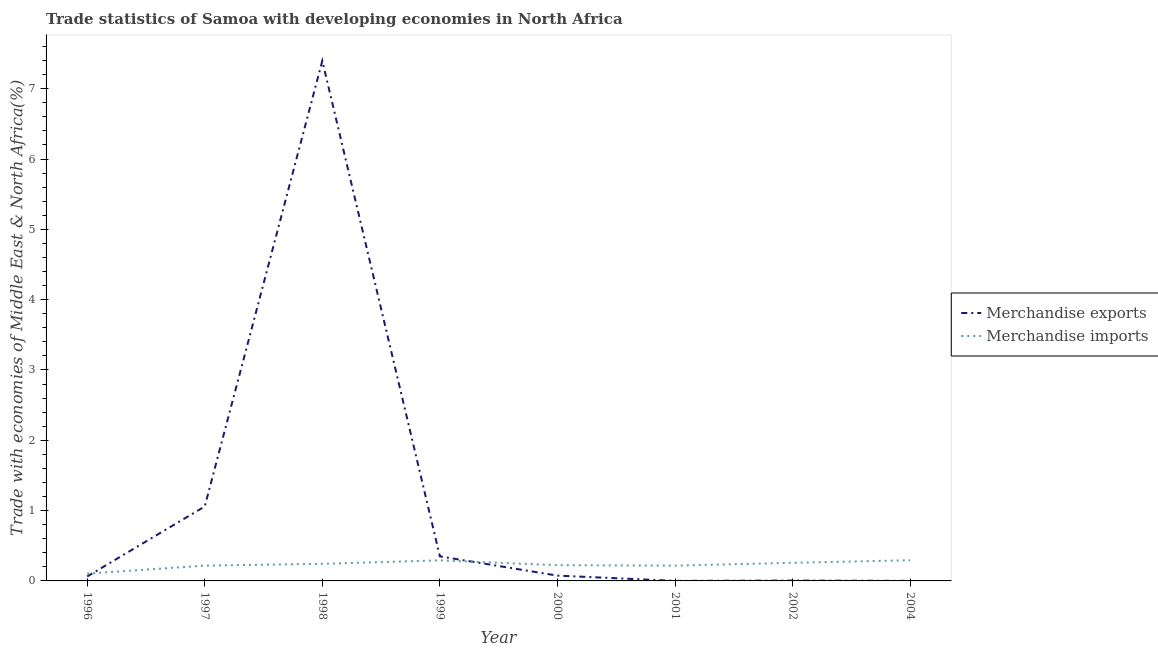Does the line corresponding to merchandise imports intersect with the line corresponding to merchandise exports?
Ensure brevity in your answer.  Yes. What is the merchandise imports in 1998?
Your answer should be compact. 0.24. Across all years, what is the maximum merchandise imports?
Keep it short and to the point. 0.29. Across all years, what is the minimum merchandise exports?
Provide a short and direct response. 0. In which year was the merchandise exports maximum?
Offer a terse response. 1998. What is the total merchandise imports in the graph?
Provide a succinct answer. 1.85. What is the difference between the merchandise exports in 1997 and that in 2001?
Your answer should be compact. 1.06. What is the difference between the merchandise imports in 1998 and the merchandise exports in 2000?
Provide a short and direct response. 0.17. What is the average merchandise imports per year?
Offer a very short reply. 0.23. In the year 1997, what is the difference between the merchandise imports and merchandise exports?
Offer a very short reply. -0.84. In how many years, is the merchandise imports greater than 1.8 %?
Your answer should be very brief. 0. What is the ratio of the merchandise exports in 1998 to that in 2004?
Your answer should be very brief. 8671.73. Is the merchandise imports in 1997 less than that in 2000?
Give a very brief answer. Yes. Is the difference between the merchandise exports in 1998 and 1999 greater than the difference between the merchandise imports in 1998 and 1999?
Give a very brief answer. Yes. What is the difference between the highest and the second highest merchandise exports?
Your answer should be very brief. 6.34. What is the difference between the highest and the lowest merchandise exports?
Make the answer very short. 7.4. Does the merchandise imports monotonically increase over the years?
Ensure brevity in your answer.  No. How many lines are there?
Offer a terse response. 2. What is the difference between two consecutive major ticks on the Y-axis?
Your answer should be compact. 1. Does the graph contain any zero values?
Ensure brevity in your answer.  No. How many legend labels are there?
Give a very brief answer. 2. What is the title of the graph?
Offer a terse response. Trade statistics of Samoa with developing economies in North Africa. Does "Females" appear as one of the legend labels in the graph?
Your answer should be compact. No. What is the label or title of the X-axis?
Ensure brevity in your answer.  Year. What is the label or title of the Y-axis?
Ensure brevity in your answer.  Trade with economies of Middle East & North Africa(%). What is the Trade with economies of Middle East & North Africa(%) of Merchandise exports in 1996?
Your response must be concise. 0.06. What is the Trade with economies of Middle East & North Africa(%) in Merchandise imports in 1996?
Ensure brevity in your answer.  0.1. What is the Trade with economies of Middle East & North Africa(%) of Merchandise exports in 1997?
Your response must be concise. 1.06. What is the Trade with economies of Middle East & North Africa(%) in Merchandise imports in 1997?
Keep it short and to the point. 0.22. What is the Trade with economies of Middle East & North Africa(%) in Merchandise exports in 1998?
Ensure brevity in your answer.  7.4. What is the Trade with economies of Middle East & North Africa(%) in Merchandise imports in 1998?
Provide a succinct answer. 0.24. What is the Trade with economies of Middle East & North Africa(%) in Merchandise exports in 1999?
Make the answer very short. 0.35. What is the Trade with economies of Middle East & North Africa(%) in Merchandise imports in 1999?
Keep it short and to the point. 0.29. What is the Trade with economies of Middle East & North Africa(%) in Merchandise exports in 2000?
Your response must be concise. 0.08. What is the Trade with economies of Middle East & North Africa(%) of Merchandise imports in 2000?
Give a very brief answer. 0.22. What is the Trade with economies of Middle East & North Africa(%) in Merchandise exports in 2001?
Make the answer very short. 0. What is the Trade with economies of Middle East & North Africa(%) of Merchandise imports in 2001?
Keep it short and to the point. 0.22. What is the Trade with economies of Middle East & North Africa(%) in Merchandise exports in 2002?
Make the answer very short. 0. What is the Trade with economies of Middle East & North Africa(%) of Merchandise imports in 2002?
Make the answer very short. 0.26. What is the Trade with economies of Middle East & North Africa(%) in Merchandise exports in 2004?
Your response must be concise. 0. What is the Trade with economies of Middle East & North Africa(%) of Merchandise imports in 2004?
Your answer should be compact. 0.29. Across all years, what is the maximum Trade with economies of Middle East & North Africa(%) in Merchandise exports?
Make the answer very short. 7.4. Across all years, what is the maximum Trade with economies of Middle East & North Africa(%) in Merchandise imports?
Ensure brevity in your answer.  0.29. Across all years, what is the minimum Trade with economies of Middle East & North Africa(%) in Merchandise exports?
Offer a terse response. 0. Across all years, what is the minimum Trade with economies of Middle East & North Africa(%) of Merchandise imports?
Your answer should be very brief. 0.1. What is the total Trade with economies of Middle East & North Africa(%) of Merchandise exports in the graph?
Offer a terse response. 8.95. What is the total Trade with economies of Middle East & North Africa(%) of Merchandise imports in the graph?
Keep it short and to the point. 1.85. What is the difference between the Trade with economies of Middle East & North Africa(%) of Merchandise exports in 1996 and that in 1997?
Make the answer very short. -1. What is the difference between the Trade with economies of Middle East & North Africa(%) in Merchandise imports in 1996 and that in 1997?
Make the answer very short. -0.11. What is the difference between the Trade with economies of Middle East & North Africa(%) of Merchandise exports in 1996 and that in 1998?
Your answer should be compact. -7.33. What is the difference between the Trade with economies of Middle East & North Africa(%) of Merchandise imports in 1996 and that in 1998?
Provide a succinct answer. -0.14. What is the difference between the Trade with economies of Middle East & North Africa(%) of Merchandise exports in 1996 and that in 1999?
Your response must be concise. -0.29. What is the difference between the Trade with economies of Middle East & North Africa(%) in Merchandise imports in 1996 and that in 1999?
Your response must be concise. -0.19. What is the difference between the Trade with economies of Middle East & North Africa(%) in Merchandise exports in 1996 and that in 2000?
Provide a short and direct response. -0.01. What is the difference between the Trade with economies of Middle East & North Africa(%) in Merchandise imports in 1996 and that in 2000?
Provide a short and direct response. -0.12. What is the difference between the Trade with economies of Middle East & North Africa(%) in Merchandise exports in 1996 and that in 2001?
Ensure brevity in your answer.  0.06. What is the difference between the Trade with economies of Middle East & North Africa(%) of Merchandise imports in 1996 and that in 2001?
Your response must be concise. -0.11. What is the difference between the Trade with economies of Middle East & North Africa(%) in Merchandise exports in 1996 and that in 2002?
Provide a short and direct response. 0.06. What is the difference between the Trade with economies of Middle East & North Africa(%) in Merchandise imports in 1996 and that in 2002?
Give a very brief answer. -0.15. What is the difference between the Trade with economies of Middle East & North Africa(%) of Merchandise exports in 1996 and that in 2004?
Ensure brevity in your answer.  0.06. What is the difference between the Trade with economies of Middle East & North Africa(%) of Merchandise imports in 1996 and that in 2004?
Keep it short and to the point. -0.19. What is the difference between the Trade with economies of Middle East & North Africa(%) in Merchandise exports in 1997 and that in 1998?
Ensure brevity in your answer.  -6.34. What is the difference between the Trade with economies of Middle East & North Africa(%) of Merchandise imports in 1997 and that in 1998?
Your answer should be compact. -0.03. What is the difference between the Trade with economies of Middle East & North Africa(%) of Merchandise exports in 1997 and that in 1999?
Your answer should be compact. 0.71. What is the difference between the Trade with economies of Middle East & North Africa(%) in Merchandise imports in 1997 and that in 1999?
Your answer should be compact. -0.07. What is the difference between the Trade with economies of Middle East & North Africa(%) in Merchandise exports in 1997 and that in 2000?
Your answer should be very brief. 0.98. What is the difference between the Trade with economies of Middle East & North Africa(%) in Merchandise imports in 1997 and that in 2000?
Give a very brief answer. -0.01. What is the difference between the Trade with economies of Middle East & North Africa(%) in Merchandise exports in 1997 and that in 2001?
Provide a succinct answer. 1.06. What is the difference between the Trade with economies of Middle East & North Africa(%) in Merchandise imports in 1997 and that in 2001?
Ensure brevity in your answer.  0. What is the difference between the Trade with economies of Middle East & North Africa(%) of Merchandise exports in 1997 and that in 2002?
Ensure brevity in your answer.  1.05. What is the difference between the Trade with economies of Middle East & North Africa(%) of Merchandise imports in 1997 and that in 2002?
Your answer should be compact. -0.04. What is the difference between the Trade with economies of Middle East & North Africa(%) of Merchandise exports in 1997 and that in 2004?
Your answer should be compact. 1.06. What is the difference between the Trade with economies of Middle East & North Africa(%) of Merchandise imports in 1997 and that in 2004?
Keep it short and to the point. -0.08. What is the difference between the Trade with economies of Middle East & North Africa(%) of Merchandise exports in 1998 and that in 1999?
Ensure brevity in your answer.  7.05. What is the difference between the Trade with economies of Middle East & North Africa(%) in Merchandise imports in 1998 and that in 1999?
Make the answer very short. -0.05. What is the difference between the Trade with economies of Middle East & North Africa(%) of Merchandise exports in 1998 and that in 2000?
Offer a very short reply. 7.32. What is the difference between the Trade with economies of Middle East & North Africa(%) of Merchandise imports in 1998 and that in 2000?
Give a very brief answer. 0.02. What is the difference between the Trade with economies of Middle East & North Africa(%) in Merchandise exports in 1998 and that in 2001?
Make the answer very short. 7.4. What is the difference between the Trade with economies of Middle East & North Africa(%) in Merchandise imports in 1998 and that in 2001?
Offer a terse response. 0.03. What is the difference between the Trade with economies of Middle East & North Africa(%) in Merchandise exports in 1998 and that in 2002?
Make the answer very short. 7.39. What is the difference between the Trade with economies of Middle East & North Africa(%) of Merchandise imports in 1998 and that in 2002?
Your response must be concise. -0.01. What is the difference between the Trade with economies of Middle East & North Africa(%) in Merchandise exports in 1998 and that in 2004?
Provide a short and direct response. 7.4. What is the difference between the Trade with economies of Middle East & North Africa(%) of Merchandise imports in 1998 and that in 2004?
Offer a terse response. -0.05. What is the difference between the Trade with economies of Middle East & North Africa(%) in Merchandise exports in 1999 and that in 2000?
Your response must be concise. 0.27. What is the difference between the Trade with economies of Middle East & North Africa(%) of Merchandise imports in 1999 and that in 2000?
Offer a very short reply. 0.07. What is the difference between the Trade with economies of Middle East & North Africa(%) of Merchandise exports in 1999 and that in 2001?
Give a very brief answer. 0.35. What is the difference between the Trade with economies of Middle East & North Africa(%) of Merchandise imports in 1999 and that in 2001?
Give a very brief answer. 0.08. What is the difference between the Trade with economies of Middle East & North Africa(%) of Merchandise exports in 1999 and that in 2002?
Your answer should be compact. 0.34. What is the difference between the Trade with economies of Middle East & North Africa(%) of Merchandise imports in 1999 and that in 2002?
Give a very brief answer. 0.04. What is the difference between the Trade with economies of Middle East & North Africa(%) in Merchandise exports in 1999 and that in 2004?
Offer a terse response. 0.35. What is the difference between the Trade with economies of Middle East & North Africa(%) of Merchandise imports in 1999 and that in 2004?
Your response must be concise. -0. What is the difference between the Trade with economies of Middle East & North Africa(%) in Merchandise exports in 2000 and that in 2001?
Your answer should be compact. 0.07. What is the difference between the Trade with economies of Middle East & North Africa(%) in Merchandise imports in 2000 and that in 2001?
Your answer should be compact. 0.01. What is the difference between the Trade with economies of Middle East & North Africa(%) of Merchandise exports in 2000 and that in 2002?
Provide a short and direct response. 0.07. What is the difference between the Trade with economies of Middle East & North Africa(%) in Merchandise imports in 2000 and that in 2002?
Provide a short and direct response. -0.03. What is the difference between the Trade with economies of Middle East & North Africa(%) of Merchandise exports in 2000 and that in 2004?
Provide a succinct answer. 0.07. What is the difference between the Trade with economies of Middle East & North Africa(%) in Merchandise imports in 2000 and that in 2004?
Your answer should be very brief. -0.07. What is the difference between the Trade with economies of Middle East & North Africa(%) in Merchandise exports in 2001 and that in 2002?
Offer a very short reply. -0. What is the difference between the Trade with economies of Middle East & North Africa(%) in Merchandise imports in 2001 and that in 2002?
Your response must be concise. -0.04. What is the difference between the Trade with economies of Middle East & North Africa(%) of Merchandise exports in 2001 and that in 2004?
Ensure brevity in your answer.  0. What is the difference between the Trade with economies of Middle East & North Africa(%) in Merchandise imports in 2001 and that in 2004?
Your answer should be compact. -0.08. What is the difference between the Trade with economies of Middle East & North Africa(%) in Merchandise exports in 2002 and that in 2004?
Make the answer very short. 0. What is the difference between the Trade with economies of Middle East & North Africa(%) in Merchandise imports in 2002 and that in 2004?
Offer a terse response. -0.04. What is the difference between the Trade with economies of Middle East & North Africa(%) of Merchandise exports in 1996 and the Trade with economies of Middle East & North Africa(%) of Merchandise imports in 1997?
Your answer should be very brief. -0.15. What is the difference between the Trade with economies of Middle East & North Africa(%) in Merchandise exports in 1996 and the Trade with economies of Middle East & North Africa(%) in Merchandise imports in 1998?
Ensure brevity in your answer.  -0.18. What is the difference between the Trade with economies of Middle East & North Africa(%) of Merchandise exports in 1996 and the Trade with economies of Middle East & North Africa(%) of Merchandise imports in 1999?
Your answer should be very brief. -0.23. What is the difference between the Trade with economies of Middle East & North Africa(%) of Merchandise exports in 1996 and the Trade with economies of Middle East & North Africa(%) of Merchandise imports in 2000?
Provide a short and direct response. -0.16. What is the difference between the Trade with economies of Middle East & North Africa(%) of Merchandise exports in 1996 and the Trade with economies of Middle East & North Africa(%) of Merchandise imports in 2001?
Your response must be concise. -0.15. What is the difference between the Trade with economies of Middle East & North Africa(%) of Merchandise exports in 1996 and the Trade with economies of Middle East & North Africa(%) of Merchandise imports in 2002?
Provide a succinct answer. -0.19. What is the difference between the Trade with economies of Middle East & North Africa(%) in Merchandise exports in 1996 and the Trade with economies of Middle East & North Africa(%) in Merchandise imports in 2004?
Your answer should be compact. -0.23. What is the difference between the Trade with economies of Middle East & North Africa(%) in Merchandise exports in 1997 and the Trade with economies of Middle East & North Africa(%) in Merchandise imports in 1998?
Ensure brevity in your answer.  0.82. What is the difference between the Trade with economies of Middle East & North Africa(%) of Merchandise exports in 1997 and the Trade with economies of Middle East & North Africa(%) of Merchandise imports in 1999?
Ensure brevity in your answer.  0.77. What is the difference between the Trade with economies of Middle East & North Africa(%) of Merchandise exports in 1997 and the Trade with economies of Middle East & North Africa(%) of Merchandise imports in 2000?
Keep it short and to the point. 0.83. What is the difference between the Trade with economies of Middle East & North Africa(%) in Merchandise exports in 1997 and the Trade with economies of Middle East & North Africa(%) in Merchandise imports in 2001?
Provide a succinct answer. 0.84. What is the difference between the Trade with economies of Middle East & North Africa(%) of Merchandise exports in 1997 and the Trade with economies of Middle East & North Africa(%) of Merchandise imports in 2002?
Offer a terse response. 0.8. What is the difference between the Trade with economies of Middle East & North Africa(%) of Merchandise exports in 1997 and the Trade with economies of Middle East & North Africa(%) of Merchandise imports in 2004?
Your answer should be compact. 0.76. What is the difference between the Trade with economies of Middle East & North Africa(%) of Merchandise exports in 1998 and the Trade with economies of Middle East & North Africa(%) of Merchandise imports in 1999?
Your answer should be compact. 7.1. What is the difference between the Trade with economies of Middle East & North Africa(%) in Merchandise exports in 1998 and the Trade with economies of Middle East & North Africa(%) in Merchandise imports in 2000?
Keep it short and to the point. 7.17. What is the difference between the Trade with economies of Middle East & North Africa(%) of Merchandise exports in 1998 and the Trade with economies of Middle East & North Africa(%) of Merchandise imports in 2001?
Offer a very short reply. 7.18. What is the difference between the Trade with economies of Middle East & North Africa(%) in Merchandise exports in 1998 and the Trade with economies of Middle East & North Africa(%) in Merchandise imports in 2002?
Keep it short and to the point. 7.14. What is the difference between the Trade with economies of Middle East & North Africa(%) in Merchandise exports in 1998 and the Trade with economies of Middle East & North Africa(%) in Merchandise imports in 2004?
Your answer should be very brief. 7.1. What is the difference between the Trade with economies of Middle East & North Africa(%) in Merchandise exports in 1999 and the Trade with economies of Middle East & North Africa(%) in Merchandise imports in 2000?
Offer a very short reply. 0.13. What is the difference between the Trade with economies of Middle East & North Africa(%) of Merchandise exports in 1999 and the Trade with economies of Middle East & North Africa(%) of Merchandise imports in 2001?
Your answer should be compact. 0.13. What is the difference between the Trade with economies of Middle East & North Africa(%) in Merchandise exports in 1999 and the Trade with economies of Middle East & North Africa(%) in Merchandise imports in 2002?
Keep it short and to the point. 0.09. What is the difference between the Trade with economies of Middle East & North Africa(%) in Merchandise exports in 1999 and the Trade with economies of Middle East & North Africa(%) in Merchandise imports in 2004?
Your answer should be very brief. 0.05. What is the difference between the Trade with economies of Middle East & North Africa(%) in Merchandise exports in 2000 and the Trade with economies of Middle East & North Africa(%) in Merchandise imports in 2001?
Your answer should be compact. -0.14. What is the difference between the Trade with economies of Middle East & North Africa(%) of Merchandise exports in 2000 and the Trade with economies of Middle East & North Africa(%) of Merchandise imports in 2002?
Your answer should be compact. -0.18. What is the difference between the Trade with economies of Middle East & North Africa(%) in Merchandise exports in 2000 and the Trade with economies of Middle East & North Africa(%) in Merchandise imports in 2004?
Provide a succinct answer. -0.22. What is the difference between the Trade with economies of Middle East & North Africa(%) in Merchandise exports in 2001 and the Trade with economies of Middle East & North Africa(%) in Merchandise imports in 2002?
Provide a succinct answer. -0.26. What is the difference between the Trade with economies of Middle East & North Africa(%) in Merchandise exports in 2001 and the Trade with economies of Middle East & North Africa(%) in Merchandise imports in 2004?
Offer a terse response. -0.29. What is the difference between the Trade with economies of Middle East & North Africa(%) of Merchandise exports in 2002 and the Trade with economies of Middle East & North Africa(%) of Merchandise imports in 2004?
Keep it short and to the point. -0.29. What is the average Trade with economies of Middle East & North Africa(%) in Merchandise exports per year?
Provide a short and direct response. 1.12. What is the average Trade with economies of Middle East & North Africa(%) of Merchandise imports per year?
Make the answer very short. 0.23. In the year 1996, what is the difference between the Trade with economies of Middle East & North Africa(%) in Merchandise exports and Trade with economies of Middle East & North Africa(%) in Merchandise imports?
Make the answer very short. -0.04. In the year 1997, what is the difference between the Trade with economies of Middle East & North Africa(%) of Merchandise exports and Trade with economies of Middle East & North Africa(%) of Merchandise imports?
Give a very brief answer. 0.84. In the year 1998, what is the difference between the Trade with economies of Middle East & North Africa(%) in Merchandise exports and Trade with economies of Middle East & North Africa(%) in Merchandise imports?
Make the answer very short. 7.15. In the year 1999, what is the difference between the Trade with economies of Middle East & North Africa(%) of Merchandise exports and Trade with economies of Middle East & North Africa(%) of Merchandise imports?
Your answer should be compact. 0.06. In the year 2000, what is the difference between the Trade with economies of Middle East & North Africa(%) of Merchandise exports and Trade with economies of Middle East & North Africa(%) of Merchandise imports?
Offer a very short reply. -0.15. In the year 2001, what is the difference between the Trade with economies of Middle East & North Africa(%) in Merchandise exports and Trade with economies of Middle East & North Africa(%) in Merchandise imports?
Your answer should be very brief. -0.22. In the year 2002, what is the difference between the Trade with economies of Middle East & North Africa(%) in Merchandise exports and Trade with economies of Middle East & North Africa(%) in Merchandise imports?
Provide a short and direct response. -0.25. In the year 2004, what is the difference between the Trade with economies of Middle East & North Africa(%) of Merchandise exports and Trade with economies of Middle East & North Africa(%) of Merchandise imports?
Provide a short and direct response. -0.29. What is the ratio of the Trade with economies of Middle East & North Africa(%) in Merchandise exports in 1996 to that in 1997?
Your answer should be very brief. 0.06. What is the ratio of the Trade with economies of Middle East & North Africa(%) in Merchandise imports in 1996 to that in 1997?
Ensure brevity in your answer.  0.48. What is the ratio of the Trade with economies of Middle East & North Africa(%) of Merchandise exports in 1996 to that in 1998?
Give a very brief answer. 0.01. What is the ratio of the Trade with economies of Middle East & North Africa(%) in Merchandise imports in 1996 to that in 1998?
Your answer should be compact. 0.43. What is the ratio of the Trade with economies of Middle East & North Africa(%) in Merchandise exports in 1996 to that in 1999?
Give a very brief answer. 0.18. What is the ratio of the Trade with economies of Middle East & North Africa(%) of Merchandise imports in 1996 to that in 1999?
Ensure brevity in your answer.  0.35. What is the ratio of the Trade with economies of Middle East & North Africa(%) in Merchandise exports in 1996 to that in 2000?
Ensure brevity in your answer.  0.84. What is the ratio of the Trade with economies of Middle East & North Africa(%) in Merchandise imports in 1996 to that in 2000?
Your answer should be very brief. 0.46. What is the ratio of the Trade with economies of Middle East & North Africa(%) of Merchandise exports in 1996 to that in 2001?
Offer a terse response. 70.3. What is the ratio of the Trade with economies of Middle East & North Africa(%) in Merchandise imports in 1996 to that in 2001?
Your answer should be compact. 0.48. What is the ratio of the Trade with economies of Middle East & North Africa(%) in Merchandise exports in 1996 to that in 2002?
Ensure brevity in your answer.  12.73. What is the ratio of the Trade with economies of Middle East & North Africa(%) of Merchandise imports in 1996 to that in 2002?
Provide a short and direct response. 0.4. What is the ratio of the Trade with economies of Middle East & North Africa(%) in Merchandise exports in 1996 to that in 2004?
Provide a short and direct response. 74.07. What is the ratio of the Trade with economies of Middle East & North Africa(%) in Merchandise imports in 1996 to that in 2004?
Ensure brevity in your answer.  0.35. What is the ratio of the Trade with economies of Middle East & North Africa(%) in Merchandise exports in 1997 to that in 1998?
Provide a succinct answer. 0.14. What is the ratio of the Trade with economies of Middle East & North Africa(%) in Merchandise imports in 1997 to that in 1998?
Ensure brevity in your answer.  0.9. What is the ratio of the Trade with economies of Middle East & North Africa(%) in Merchandise exports in 1997 to that in 1999?
Your answer should be very brief. 3.03. What is the ratio of the Trade with economies of Middle East & North Africa(%) of Merchandise imports in 1997 to that in 1999?
Your response must be concise. 0.74. What is the ratio of the Trade with economies of Middle East & North Africa(%) of Merchandise exports in 1997 to that in 2000?
Your answer should be compact. 14.04. What is the ratio of the Trade with economies of Middle East & North Africa(%) of Merchandise imports in 1997 to that in 2000?
Give a very brief answer. 0.97. What is the ratio of the Trade with economies of Middle East & North Africa(%) of Merchandise exports in 1997 to that in 2001?
Keep it short and to the point. 1178.15. What is the ratio of the Trade with economies of Middle East & North Africa(%) in Merchandise imports in 1997 to that in 2001?
Your answer should be very brief. 1. What is the ratio of the Trade with economies of Middle East & North Africa(%) in Merchandise exports in 1997 to that in 2002?
Offer a very short reply. 213.34. What is the ratio of the Trade with economies of Middle East & North Africa(%) in Merchandise imports in 1997 to that in 2002?
Provide a succinct answer. 0.85. What is the ratio of the Trade with economies of Middle East & North Africa(%) in Merchandise exports in 1997 to that in 2004?
Give a very brief answer. 1241.43. What is the ratio of the Trade with economies of Middle East & North Africa(%) in Merchandise imports in 1997 to that in 2004?
Ensure brevity in your answer.  0.74. What is the ratio of the Trade with economies of Middle East & North Africa(%) of Merchandise exports in 1998 to that in 1999?
Your answer should be compact. 21.19. What is the ratio of the Trade with economies of Middle East & North Africa(%) of Merchandise imports in 1998 to that in 1999?
Give a very brief answer. 0.83. What is the ratio of the Trade with economies of Middle East & North Africa(%) of Merchandise exports in 1998 to that in 2000?
Your response must be concise. 98.08. What is the ratio of the Trade with economies of Middle East & North Africa(%) in Merchandise imports in 1998 to that in 2000?
Your answer should be very brief. 1.09. What is the ratio of the Trade with economies of Middle East & North Africa(%) in Merchandise exports in 1998 to that in 2001?
Give a very brief answer. 8229.69. What is the ratio of the Trade with economies of Middle East & North Africa(%) of Merchandise imports in 1998 to that in 2001?
Ensure brevity in your answer.  1.12. What is the ratio of the Trade with economies of Middle East & North Africa(%) of Merchandise exports in 1998 to that in 2002?
Make the answer very short. 1490.23. What is the ratio of the Trade with economies of Middle East & North Africa(%) in Merchandise imports in 1998 to that in 2002?
Ensure brevity in your answer.  0.94. What is the ratio of the Trade with economies of Middle East & North Africa(%) in Merchandise exports in 1998 to that in 2004?
Make the answer very short. 8671.73. What is the ratio of the Trade with economies of Middle East & North Africa(%) of Merchandise imports in 1998 to that in 2004?
Ensure brevity in your answer.  0.83. What is the ratio of the Trade with economies of Middle East & North Africa(%) of Merchandise exports in 1999 to that in 2000?
Provide a short and direct response. 4.63. What is the ratio of the Trade with economies of Middle East & North Africa(%) in Merchandise imports in 1999 to that in 2000?
Offer a terse response. 1.31. What is the ratio of the Trade with economies of Middle East & North Africa(%) of Merchandise exports in 1999 to that in 2001?
Your answer should be very brief. 388.39. What is the ratio of the Trade with economies of Middle East & North Africa(%) in Merchandise imports in 1999 to that in 2001?
Keep it short and to the point. 1.35. What is the ratio of the Trade with economies of Middle East & North Africa(%) in Merchandise exports in 1999 to that in 2002?
Keep it short and to the point. 70.33. What is the ratio of the Trade with economies of Middle East & North Africa(%) in Merchandise imports in 1999 to that in 2002?
Ensure brevity in your answer.  1.14. What is the ratio of the Trade with economies of Middle East & North Africa(%) in Merchandise exports in 1999 to that in 2004?
Offer a terse response. 409.25. What is the ratio of the Trade with economies of Middle East & North Africa(%) of Merchandise exports in 2000 to that in 2001?
Your answer should be compact. 83.91. What is the ratio of the Trade with economies of Middle East & North Africa(%) of Merchandise imports in 2000 to that in 2001?
Your answer should be compact. 1.03. What is the ratio of the Trade with economies of Middle East & North Africa(%) of Merchandise exports in 2000 to that in 2002?
Your response must be concise. 15.19. What is the ratio of the Trade with economies of Middle East & North Africa(%) of Merchandise imports in 2000 to that in 2002?
Keep it short and to the point. 0.87. What is the ratio of the Trade with economies of Middle East & North Africa(%) in Merchandise exports in 2000 to that in 2004?
Make the answer very short. 88.41. What is the ratio of the Trade with economies of Middle East & North Africa(%) of Merchandise imports in 2000 to that in 2004?
Offer a terse response. 0.76. What is the ratio of the Trade with economies of Middle East & North Africa(%) in Merchandise exports in 2001 to that in 2002?
Give a very brief answer. 0.18. What is the ratio of the Trade with economies of Middle East & North Africa(%) of Merchandise imports in 2001 to that in 2002?
Your answer should be compact. 0.84. What is the ratio of the Trade with economies of Middle East & North Africa(%) in Merchandise exports in 2001 to that in 2004?
Your response must be concise. 1.05. What is the ratio of the Trade with economies of Middle East & North Africa(%) of Merchandise imports in 2001 to that in 2004?
Your response must be concise. 0.74. What is the ratio of the Trade with economies of Middle East & North Africa(%) in Merchandise exports in 2002 to that in 2004?
Your response must be concise. 5.82. What is the ratio of the Trade with economies of Middle East & North Africa(%) in Merchandise imports in 2002 to that in 2004?
Your answer should be compact. 0.88. What is the difference between the highest and the second highest Trade with economies of Middle East & North Africa(%) of Merchandise exports?
Your answer should be compact. 6.34. What is the difference between the highest and the second highest Trade with economies of Middle East & North Africa(%) in Merchandise imports?
Make the answer very short. 0. What is the difference between the highest and the lowest Trade with economies of Middle East & North Africa(%) of Merchandise exports?
Keep it short and to the point. 7.4. What is the difference between the highest and the lowest Trade with economies of Middle East & North Africa(%) in Merchandise imports?
Ensure brevity in your answer.  0.19. 